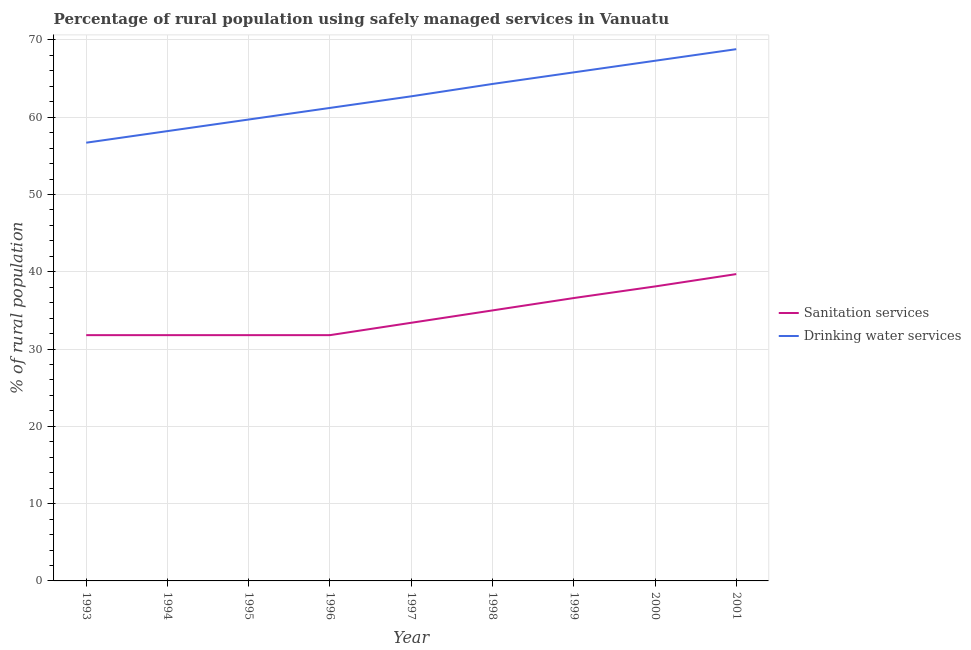What is the percentage of rural population who used drinking water services in 2000?
Your response must be concise. 67.3. Across all years, what is the maximum percentage of rural population who used sanitation services?
Provide a succinct answer. 39.7. Across all years, what is the minimum percentage of rural population who used sanitation services?
Keep it short and to the point. 31.8. In which year was the percentage of rural population who used sanitation services maximum?
Your answer should be very brief. 2001. In which year was the percentage of rural population who used drinking water services minimum?
Offer a very short reply. 1993. What is the total percentage of rural population who used drinking water services in the graph?
Give a very brief answer. 564.7. What is the difference between the percentage of rural population who used drinking water services in 1993 and that in 1999?
Your answer should be compact. -9.1. What is the difference between the percentage of rural population who used drinking water services in 2000 and the percentage of rural population who used sanitation services in 1995?
Make the answer very short. 35.5. What is the average percentage of rural population who used sanitation services per year?
Your answer should be very brief. 34.44. In the year 1996, what is the difference between the percentage of rural population who used sanitation services and percentage of rural population who used drinking water services?
Offer a terse response. -29.4. What is the ratio of the percentage of rural population who used drinking water services in 1995 to that in 2000?
Offer a terse response. 0.89. Is the percentage of rural population who used drinking water services in 1998 less than that in 2001?
Give a very brief answer. Yes. What is the difference between the highest and the second highest percentage of rural population who used drinking water services?
Offer a terse response. 1.5. What is the difference between the highest and the lowest percentage of rural population who used drinking water services?
Your answer should be compact. 12.1. In how many years, is the percentage of rural population who used sanitation services greater than the average percentage of rural population who used sanitation services taken over all years?
Offer a terse response. 4. Is the percentage of rural population who used drinking water services strictly less than the percentage of rural population who used sanitation services over the years?
Your answer should be very brief. No. What is the difference between two consecutive major ticks on the Y-axis?
Your response must be concise. 10. Does the graph contain grids?
Provide a succinct answer. Yes. How many legend labels are there?
Make the answer very short. 2. What is the title of the graph?
Provide a short and direct response. Percentage of rural population using safely managed services in Vanuatu. What is the label or title of the X-axis?
Ensure brevity in your answer.  Year. What is the label or title of the Y-axis?
Give a very brief answer. % of rural population. What is the % of rural population of Sanitation services in 1993?
Your answer should be very brief. 31.8. What is the % of rural population of Drinking water services in 1993?
Ensure brevity in your answer.  56.7. What is the % of rural population of Sanitation services in 1994?
Keep it short and to the point. 31.8. What is the % of rural population of Drinking water services in 1994?
Make the answer very short. 58.2. What is the % of rural population of Sanitation services in 1995?
Ensure brevity in your answer.  31.8. What is the % of rural population in Drinking water services in 1995?
Make the answer very short. 59.7. What is the % of rural population in Sanitation services in 1996?
Make the answer very short. 31.8. What is the % of rural population in Drinking water services in 1996?
Offer a terse response. 61.2. What is the % of rural population of Sanitation services in 1997?
Offer a terse response. 33.4. What is the % of rural population of Drinking water services in 1997?
Your response must be concise. 62.7. What is the % of rural population in Drinking water services in 1998?
Keep it short and to the point. 64.3. What is the % of rural population of Sanitation services in 1999?
Your response must be concise. 36.6. What is the % of rural population in Drinking water services in 1999?
Provide a short and direct response. 65.8. What is the % of rural population in Sanitation services in 2000?
Your response must be concise. 38.1. What is the % of rural population of Drinking water services in 2000?
Your response must be concise. 67.3. What is the % of rural population of Sanitation services in 2001?
Ensure brevity in your answer.  39.7. What is the % of rural population of Drinking water services in 2001?
Keep it short and to the point. 68.8. Across all years, what is the maximum % of rural population of Sanitation services?
Provide a succinct answer. 39.7. Across all years, what is the maximum % of rural population of Drinking water services?
Provide a succinct answer. 68.8. Across all years, what is the minimum % of rural population in Sanitation services?
Offer a terse response. 31.8. Across all years, what is the minimum % of rural population in Drinking water services?
Make the answer very short. 56.7. What is the total % of rural population in Sanitation services in the graph?
Offer a terse response. 310. What is the total % of rural population in Drinking water services in the graph?
Give a very brief answer. 564.7. What is the difference between the % of rural population in Sanitation services in 1993 and that in 1994?
Give a very brief answer. 0. What is the difference between the % of rural population of Sanitation services in 1993 and that in 1995?
Keep it short and to the point. 0. What is the difference between the % of rural population of Sanitation services in 1993 and that in 1996?
Give a very brief answer. 0. What is the difference between the % of rural population in Drinking water services in 1993 and that in 1996?
Your response must be concise. -4.5. What is the difference between the % of rural population in Sanitation services in 1993 and that in 1997?
Provide a succinct answer. -1.6. What is the difference between the % of rural population in Drinking water services in 1993 and that in 1997?
Provide a succinct answer. -6. What is the difference between the % of rural population of Sanitation services in 1993 and that in 1998?
Make the answer very short. -3.2. What is the difference between the % of rural population in Drinking water services in 1993 and that in 1998?
Provide a succinct answer. -7.6. What is the difference between the % of rural population in Sanitation services in 1993 and that in 1999?
Your response must be concise. -4.8. What is the difference between the % of rural population of Drinking water services in 1993 and that in 1999?
Your answer should be compact. -9.1. What is the difference between the % of rural population in Sanitation services in 1993 and that in 2000?
Provide a short and direct response. -6.3. What is the difference between the % of rural population of Drinking water services in 1993 and that in 2000?
Offer a terse response. -10.6. What is the difference between the % of rural population of Drinking water services in 1993 and that in 2001?
Your response must be concise. -12.1. What is the difference between the % of rural population of Drinking water services in 1994 and that in 1995?
Make the answer very short. -1.5. What is the difference between the % of rural population in Sanitation services in 1994 and that in 1996?
Offer a terse response. 0. What is the difference between the % of rural population in Drinking water services in 1994 and that in 1996?
Ensure brevity in your answer.  -3. What is the difference between the % of rural population in Drinking water services in 1994 and that in 1997?
Provide a short and direct response. -4.5. What is the difference between the % of rural population of Sanitation services in 1994 and that in 1998?
Keep it short and to the point. -3.2. What is the difference between the % of rural population of Drinking water services in 1994 and that in 1999?
Give a very brief answer. -7.6. What is the difference between the % of rural population in Sanitation services in 1994 and that in 2000?
Make the answer very short. -6.3. What is the difference between the % of rural population of Drinking water services in 1994 and that in 2000?
Offer a very short reply. -9.1. What is the difference between the % of rural population in Sanitation services in 1995 and that in 1996?
Provide a succinct answer. 0. What is the difference between the % of rural population of Drinking water services in 1995 and that in 1996?
Offer a terse response. -1.5. What is the difference between the % of rural population of Sanitation services in 1995 and that in 1997?
Provide a succinct answer. -1.6. What is the difference between the % of rural population in Drinking water services in 1995 and that in 1997?
Your response must be concise. -3. What is the difference between the % of rural population in Sanitation services in 1995 and that in 1998?
Keep it short and to the point. -3.2. What is the difference between the % of rural population in Drinking water services in 1995 and that in 1998?
Your answer should be compact. -4.6. What is the difference between the % of rural population of Drinking water services in 1995 and that in 1999?
Provide a short and direct response. -6.1. What is the difference between the % of rural population of Sanitation services in 1995 and that in 2000?
Provide a short and direct response. -6.3. What is the difference between the % of rural population in Sanitation services in 1996 and that in 1998?
Your answer should be compact. -3.2. What is the difference between the % of rural population in Drinking water services in 1996 and that in 1998?
Offer a very short reply. -3.1. What is the difference between the % of rural population of Sanitation services in 1996 and that in 1999?
Make the answer very short. -4.8. What is the difference between the % of rural population of Drinking water services in 1996 and that in 1999?
Provide a short and direct response. -4.6. What is the difference between the % of rural population in Sanitation services in 1996 and that in 2000?
Ensure brevity in your answer.  -6.3. What is the difference between the % of rural population in Sanitation services in 1996 and that in 2001?
Provide a short and direct response. -7.9. What is the difference between the % of rural population in Sanitation services in 1997 and that in 1998?
Your response must be concise. -1.6. What is the difference between the % of rural population in Sanitation services in 1997 and that in 1999?
Your response must be concise. -3.2. What is the difference between the % of rural population of Drinking water services in 1997 and that in 2000?
Keep it short and to the point. -4.6. What is the difference between the % of rural population in Drinking water services in 1997 and that in 2001?
Your answer should be very brief. -6.1. What is the difference between the % of rural population of Sanitation services in 1998 and that in 1999?
Provide a succinct answer. -1.6. What is the difference between the % of rural population in Drinking water services in 1998 and that in 2000?
Your response must be concise. -3. What is the difference between the % of rural population of Drinking water services in 1998 and that in 2001?
Provide a succinct answer. -4.5. What is the difference between the % of rural population of Drinking water services in 1999 and that in 2000?
Offer a very short reply. -1.5. What is the difference between the % of rural population of Drinking water services in 1999 and that in 2001?
Give a very brief answer. -3. What is the difference between the % of rural population of Sanitation services in 2000 and that in 2001?
Your response must be concise. -1.6. What is the difference between the % of rural population of Sanitation services in 1993 and the % of rural population of Drinking water services in 1994?
Your answer should be compact. -26.4. What is the difference between the % of rural population of Sanitation services in 1993 and the % of rural population of Drinking water services in 1995?
Make the answer very short. -27.9. What is the difference between the % of rural population of Sanitation services in 1993 and the % of rural population of Drinking water services in 1996?
Your answer should be compact. -29.4. What is the difference between the % of rural population of Sanitation services in 1993 and the % of rural population of Drinking water services in 1997?
Keep it short and to the point. -30.9. What is the difference between the % of rural population in Sanitation services in 1993 and the % of rural population in Drinking water services in 1998?
Make the answer very short. -32.5. What is the difference between the % of rural population in Sanitation services in 1993 and the % of rural population in Drinking water services in 1999?
Ensure brevity in your answer.  -34. What is the difference between the % of rural population of Sanitation services in 1993 and the % of rural population of Drinking water services in 2000?
Ensure brevity in your answer.  -35.5. What is the difference between the % of rural population of Sanitation services in 1993 and the % of rural population of Drinking water services in 2001?
Provide a succinct answer. -37. What is the difference between the % of rural population in Sanitation services in 1994 and the % of rural population in Drinking water services in 1995?
Your answer should be very brief. -27.9. What is the difference between the % of rural population in Sanitation services in 1994 and the % of rural population in Drinking water services in 1996?
Provide a short and direct response. -29.4. What is the difference between the % of rural population of Sanitation services in 1994 and the % of rural population of Drinking water services in 1997?
Ensure brevity in your answer.  -30.9. What is the difference between the % of rural population in Sanitation services in 1994 and the % of rural population in Drinking water services in 1998?
Offer a terse response. -32.5. What is the difference between the % of rural population of Sanitation services in 1994 and the % of rural population of Drinking water services in 1999?
Your answer should be compact. -34. What is the difference between the % of rural population of Sanitation services in 1994 and the % of rural population of Drinking water services in 2000?
Ensure brevity in your answer.  -35.5. What is the difference between the % of rural population of Sanitation services in 1994 and the % of rural population of Drinking water services in 2001?
Provide a short and direct response. -37. What is the difference between the % of rural population of Sanitation services in 1995 and the % of rural population of Drinking water services in 1996?
Your answer should be compact. -29.4. What is the difference between the % of rural population in Sanitation services in 1995 and the % of rural population in Drinking water services in 1997?
Provide a short and direct response. -30.9. What is the difference between the % of rural population in Sanitation services in 1995 and the % of rural population in Drinking water services in 1998?
Provide a short and direct response. -32.5. What is the difference between the % of rural population in Sanitation services in 1995 and the % of rural population in Drinking water services in 1999?
Your answer should be very brief. -34. What is the difference between the % of rural population in Sanitation services in 1995 and the % of rural population in Drinking water services in 2000?
Your answer should be very brief. -35.5. What is the difference between the % of rural population in Sanitation services in 1995 and the % of rural population in Drinking water services in 2001?
Provide a short and direct response. -37. What is the difference between the % of rural population of Sanitation services in 1996 and the % of rural population of Drinking water services in 1997?
Make the answer very short. -30.9. What is the difference between the % of rural population of Sanitation services in 1996 and the % of rural population of Drinking water services in 1998?
Give a very brief answer. -32.5. What is the difference between the % of rural population in Sanitation services in 1996 and the % of rural population in Drinking water services in 1999?
Give a very brief answer. -34. What is the difference between the % of rural population in Sanitation services in 1996 and the % of rural population in Drinking water services in 2000?
Your answer should be compact. -35.5. What is the difference between the % of rural population in Sanitation services in 1996 and the % of rural population in Drinking water services in 2001?
Ensure brevity in your answer.  -37. What is the difference between the % of rural population in Sanitation services in 1997 and the % of rural population in Drinking water services in 1998?
Provide a short and direct response. -30.9. What is the difference between the % of rural population of Sanitation services in 1997 and the % of rural population of Drinking water services in 1999?
Provide a succinct answer. -32.4. What is the difference between the % of rural population of Sanitation services in 1997 and the % of rural population of Drinking water services in 2000?
Your answer should be very brief. -33.9. What is the difference between the % of rural population in Sanitation services in 1997 and the % of rural population in Drinking water services in 2001?
Make the answer very short. -35.4. What is the difference between the % of rural population in Sanitation services in 1998 and the % of rural population in Drinking water services in 1999?
Provide a succinct answer. -30.8. What is the difference between the % of rural population in Sanitation services in 1998 and the % of rural population in Drinking water services in 2000?
Your answer should be very brief. -32.3. What is the difference between the % of rural population in Sanitation services in 1998 and the % of rural population in Drinking water services in 2001?
Keep it short and to the point. -33.8. What is the difference between the % of rural population in Sanitation services in 1999 and the % of rural population in Drinking water services in 2000?
Offer a very short reply. -30.7. What is the difference between the % of rural population of Sanitation services in 1999 and the % of rural population of Drinking water services in 2001?
Your answer should be very brief. -32.2. What is the difference between the % of rural population in Sanitation services in 2000 and the % of rural population in Drinking water services in 2001?
Give a very brief answer. -30.7. What is the average % of rural population of Sanitation services per year?
Provide a succinct answer. 34.44. What is the average % of rural population in Drinking water services per year?
Offer a terse response. 62.74. In the year 1993, what is the difference between the % of rural population in Sanitation services and % of rural population in Drinking water services?
Offer a terse response. -24.9. In the year 1994, what is the difference between the % of rural population of Sanitation services and % of rural population of Drinking water services?
Your response must be concise. -26.4. In the year 1995, what is the difference between the % of rural population in Sanitation services and % of rural population in Drinking water services?
Keep it short and to the point. -27.9. In the year 1996, what is the difference between the % of rural population in Sanitation services and % of rural population in Drinking water services?
Provide a succinct answer. -29.4. In the year 1997, what is the difference between the % of rural population in Sanitation services and % of rural population in Drinking water services?
Make the answer very short. -29.3. In the year 1998, what is the difference between the % of rural population in Sanitation services and % of rural population in Drinking water services?
Your answer should be very brief. -29.3. In the year 1999, what is the difference between the % of rural population in Sanitation services and % of rural population in Drinking water services?
Your answer should be very brief. -29.2. In the year 2000, what is the difference between the % of rural population of Sanitation services and % of rural population of Drinking water services?
Keep it short and to the point. -29.2. In the year 2001, what is the difference between the % of rural population in Sanitation services and % of rural population in Drinking water services?
Offer a very short reply. -29.1. What is the ratio of the % of rural population of Sanitation services in 1993 to that in 1994?
Your answer should be compact. 1. What is the ratio of the % of rural population in Drinking water services in 1993 to that in 1994?
Give a very brief answer. 0.97. What is the ratio of the % of rural population of Drinking water services in 1993 to that in 1995?
Your answer should be very brief. 0.95. What is the ratio of the % of rural population of Drinking water services in 1993 to that in 1996?
Provide a short and direct response. 0.93. What is the ratio of the % of rural population of Sanitation services in 1993 to that in 1997?
Ensure brevity in your answer.  0.95. What is the ratio of the % of rural population of Drinking water services in 1993 to that in 1997?
Your answer should be very brief. 0.9. What is the ratio of the % of rural population of Sanitation services in 1993 to that in 1998?
Ensure brevity in your answer.  0.91. What is the ratio of the % of rural population of Drinking water services in 1993 to that in 1998?
Keep it short and to the point. 0.88. What is the ratio of the % of rural population in Sanitation services in 1993 to that in 1999?
Your answer should be compact. 0.87. What is the ratio of the % of rural population of Drinking water services in 1993 to that in 1999?
Ensure brevity in your answer.  0.86. What is the ratio of the % of rural population in Sanitation services in 1993 to that in 2000?
Keep it short and to the point. 0.83. What is the ratio of the % of rural population in Drinking water services in 1993 to that in 2000?
Provide a succinct answer. 0.84. What is the ratio of the % of rural population of Sanitation services in 1993 to that in 2001?
Offer a terse response. 0.8. What is the ratio of the % of rural population in Drinking water services in 1993 to that in 2001?
Your answer should be very brief. 0.82. What is the ratio of the % of rural population of Sanitation services in 1994 to that in 1995?
Provide a succinct answer. 1. What is the ratio of the % of rural population of Drinking water services in 1994 to that in 1995?
Your response must be concise. 0.97. What is the ratio of the % of rural population of Sanitation services in 1994 to that in 1996?
Offer a terse response. 1. What is the ratio of the % of rural population in Drinking water services in 1994 to that in 1996?
Provide a succinct answer. 0.95. What is the ratio of the % of rural population of Sanitation services in 1994 to that in 1997?
Your answer should be very brief. 0.95. What is the ratio of the % of rural population in Drinking water services in 1994 to that in 1997?
Your response must be concise. 0.93. What is the ratio of the % of rural population in Sanitation services in 1994 to that in 1998?
Make the answer very short. 0.91. What is the ratio of the % of rural population of Drinking water services in 1994 to that in 1998?
Your response must be concise. 0.91. What is the ratio of the % of rural population in Sanitation services in 1994 to that in 1999?
Your response must be concise. 0.87. What is the ratio of the % of rural population of Drinking water services in 1994 to that in 1999?
Provide a succinct answer. 0.88. What is the ratio of the % of rural population of Sanitation services in 1994 to that in 2000?
Your answer should be compact. 0.83. What is the ratio of the % of rural population in Drinking water services in 1994 to that in 2000?
Provide a short and direct response. 0.86. What is the ratio of the % of rural population of Sanitation services in 1994 to that in 2001?
Provide a succinct answer. 0.8. What is the ratio of the % of rural population of Drinking water services in 1994 to that in 2001?
Keep it short and to the point. 0.85. What is the ratio of the % of rural population of Drinking water services in 1995 to that in 1996?
Your answer should be compact. 0.98. What is the ratio of the % of rural population of Sanitation services in 1995 to that in 1997?
Provide a short and direct response. 0.95. What is the ratio of the % of rural population of Drinking water services in 1995 to that in 1997?
Provide a succinct answer. 0.95. What is the ratio of the % of rural population in Sanitation services in 1995 to that in 1998?
Make the answer very short. 0.91. What is the ratio of the % of rural population of Drinking water services in 1995 to that in 1998?
Make the answer very short. 0.93. What is the ratio of the % of rural population in Sanitation services in 1995 to that in 1999?
Keep it short and to the point. 0.87. What is the ratio of the % of rural population of Drinking water services in 1995 to that in 1999?
Offer a terse response. 0.91. What is the ratio of the % of rural population of Sanitation services in 1995 to that in 2000?
Ensure brevity in your answer.  0.83. What is the ratio of the % of rural population in Drinking water services in 1995 to that in 2000?
Offer a very short reply. 0.89. What is the ratio of the % of rural population of Sanitation services in 1995 to that in 2001?
Ensure brevity in your answer.  0.8. What is the ratio of the % of rural population of Drinking water services in 1995 to that in 2001?
Make the answer very short. 0.87. What is the ratio of the % of rural population in Sanitation services in 1996 to that in 1997?
Make the answer very short. 0.95. What is the ratio of the % of rural population of Drinking water services in 1996 to that in 1997?
Keep it short and to the point. 0.98. What is the ratio of the % of rural population in Sanitation services in 1996 to that in 1998?
Offer a very short reply. 0.91. What is the ratio of the % of rural population in Drinking water services in 1996 to that in 1998?
Offer a very short reply. 0.95. What is the ratio of the % of rural population of Sanitation services in 1996 to that in 1999?
Give a very brief answer. 0.87. What is the ratio of the % of rural population in Drinking water services in 1996 to that in 1999?
Ensure brevity in your answer.  0.93. What is the ratio of the % of rural population in Sanitation services in 1996 to that in 2000?
Offer a terse response. 0.83. What is the ratio of the % of rural population in Drinking water services in 1996 to that in 2000?
Offer a terse response. 0.91. What is the ratio of the % of rural population of Sanitation services in 1996 to that in 2001?
Make the answer very short. 0.8. What is the ratio of the % of rural population in Drinking water services in 1996 to that in 2001?
Ensure brevity in your answer.  0.89. What is the ratio of the % of rural population of Sanitation services in 1997 to that in 1998?
Offer a terse response. 0.95. What is the ratio of the % of rural population of Drinking water services in 1997 to that in 1998?
Your answer should be very brief. 0.98. What is the ratio of the % of rural population of Sanitation services in 1997 to that in 1999?
Your response must be concise. 0.91. What is the ratio of the % of rural population of Drinking water services in 1997 to that in 1999?
Offer a very short reply. 0.95. What is the ratio of the % of rural population of Sanitation services in 1997 to that in 2000?
Offer a very short reply. 0.88. What is the ratio of the % of rural population of Drinking water services in 1997 to that in 2000?
Offer a terse response. 0.93. What is the ratio of the % of rural population of Sanitation services in 1997 to that in 2001?
Keep it short and to the point. 0.84. What is the ratio of the % of rural population in Drinking water services in 1997 to that in 2001?
Offer a very short reply. 0.91. What is the ratio of the % of rural population of Sanitation services in 1998 to that in 1999?
Offer a very short reply. 0.96. What is the ratio of the % of rural population in Drinking water services in 1998 to that in 1999?
Provide a succinct answer. 0.98. What is the ratio of the % of rural population of Sanitation services in 1998 to that in 2000?
Provide a succinct answer. 0.92. What is the ratio of the % of rural population in Drinking water services in 1998 to that in 2000?
Offer a terse response. 0.96. What is the ratio of the % of rural population of Sanitation services in 1998 to that in 2001?
Offer a terse response. 0.88. What is the ratio of the % of rural population of Drinking water services in 1998 to that in 2001?
Your response must be concise. 0.93. What is the ratio of the % of rural population in Sanitation services in 1999 to that in 2000?
Your response must be concise. 0.96. What is the ratio of the % of rural population in Drinking water services in 1999 to that in 2000?
Your answer should be very brief. 0.98. What is the ratio of the % of rural population in Sanitation services in 1999 to that in 2001?
Your answer should be compact. 0.92. What is the ratio of the % of rural population of Drinking water services in 1999 to that in 2001?
Give a very brief answer. 0.96. What is the ratio of the % of rural population in Sanitation services in 2000 to that in 2001?
Make the answer very short. 0.96. What is the ratio of the % of rural population of Drinking water services in 2000 to that in 2001?
Your answer should be very brief. 0.98. What is the difference between the highest and the second highest % of rural population of Sanitation services?
Your answer should be very brief. 1.6. What is the difference between the highest and the lowest % of rural population of Sanitation services?
Offer a terse response. 7.9. 